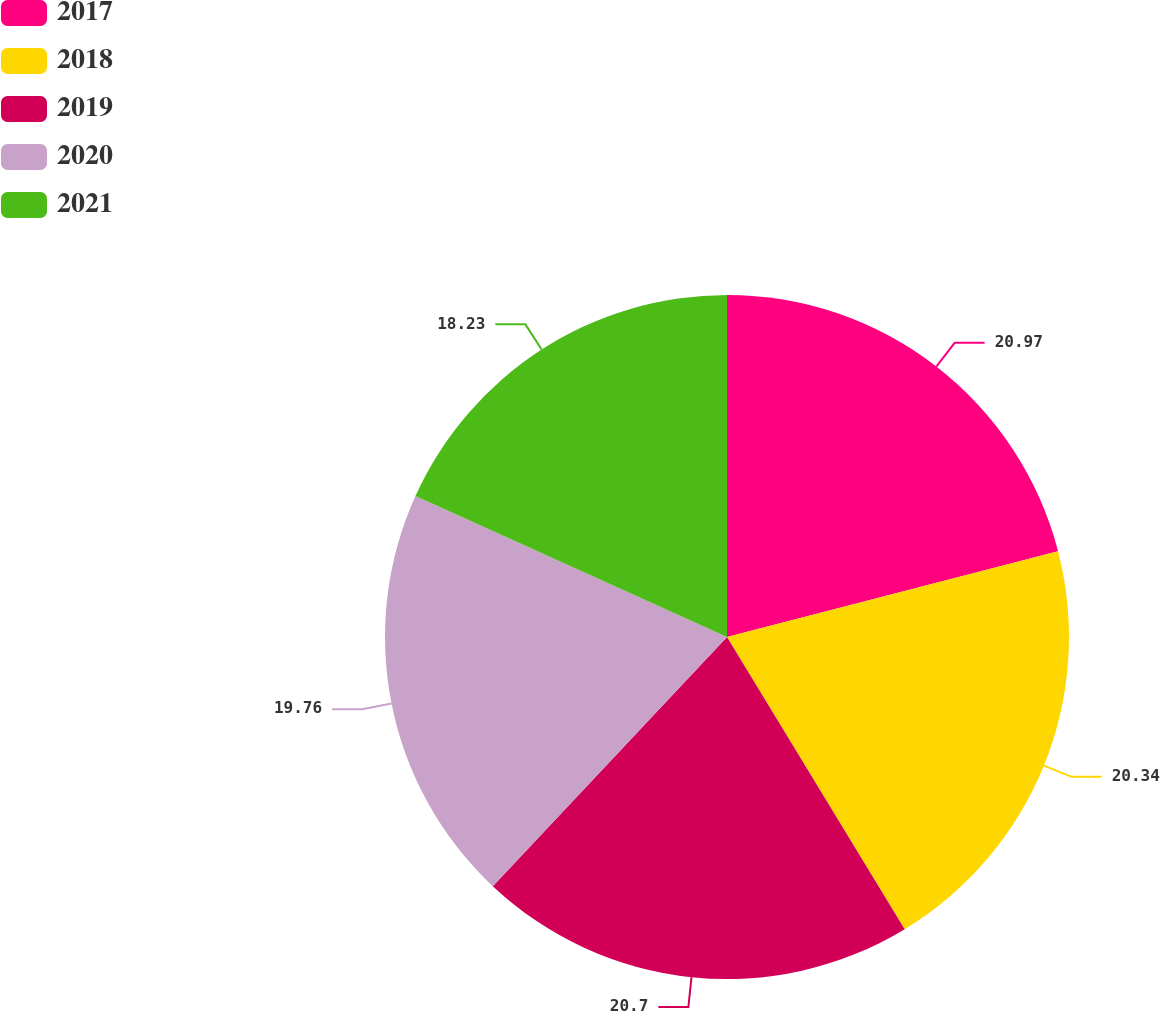Convert chart. <chart><loc_0><loc_0><loc_500><loc_500><pie_chart><fcel>2017<fcel>2018<fcel>2019<fcel>2020<fcel>2021<nl><fcel>20.96%<fcel>20.34%<fcel>20.7%<fcel>19.76%<fcel>18.23%<nl></chart> 